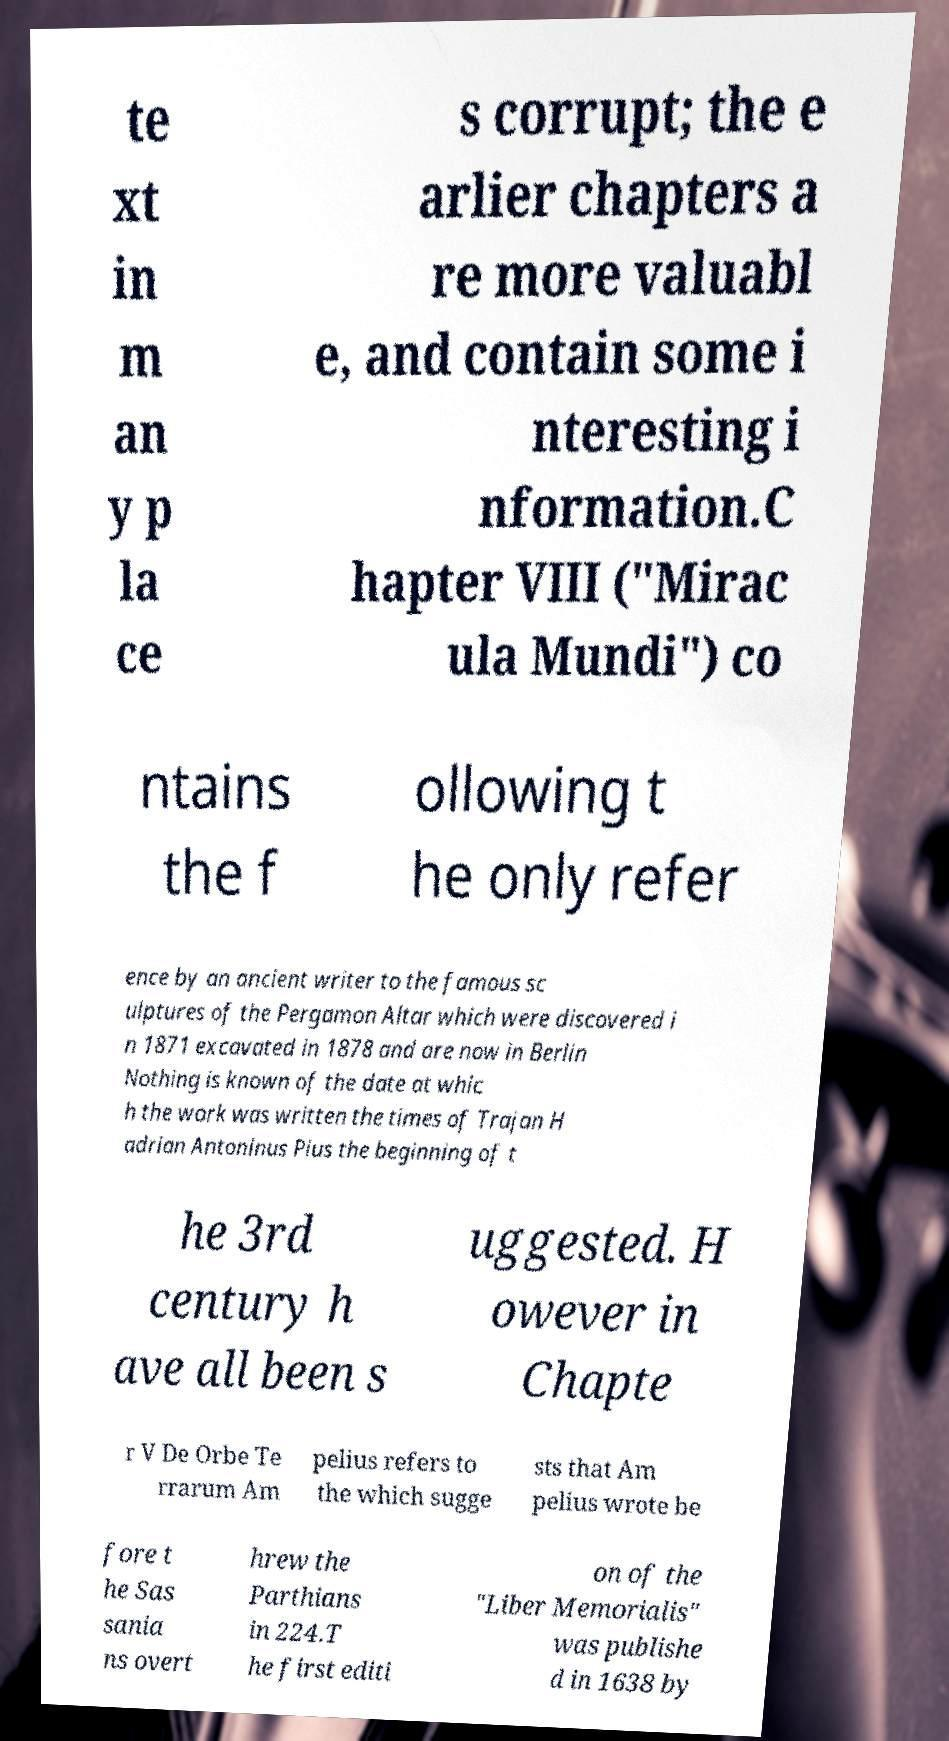Can you accurately transcribe the text from the provided image for me? te xt in m an y p la ce s corrupt; the e arlier chapters a re more valuabl e, and contain some i nteresting i nformation.C hapter VIII ("Mirac ula Mundi") co ntains the f ollowing t he only refer ence by an ancient writer to the famous sc ulptures of the Pergamon Altar which were discovered i n 1871 excavated in 1878 and are now in Berlin Nothing is known of the date at whic h the work was written the times of Trajan H adrian Antoninus Pius the beginning of t he 3rd century h ave all been s uggested. H owever in Chapte r V De Orbe Te rrarum Am pelius refers to the which sugge sts that Am pelius wrote be fore t he Sas sania ns overt hrew the Parthians in 224.T he first editi on of the "Liber Memorialis" was publishe d in 1638 by 